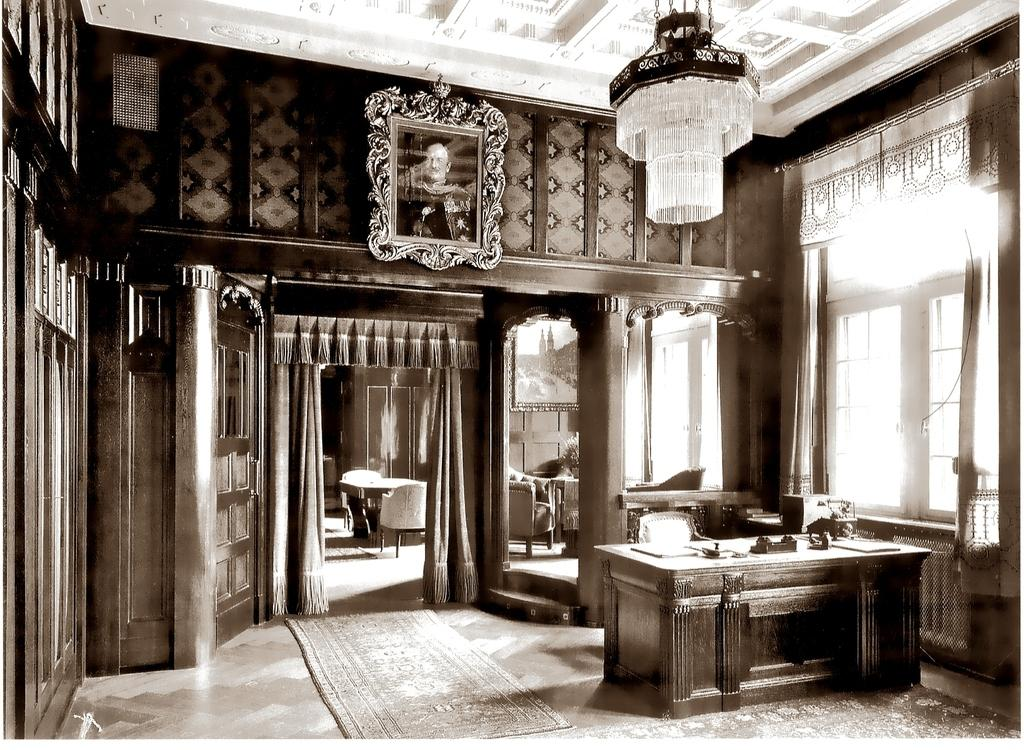What type of space is depicted in the image? The image shows an interior view of a building. What furniture is present in the image? There is a table and chairs in the image. What architectural features can be seen in the image? Windows, a wall, and the roof are visible in the image. How are the windows treated in the image? Curtains are associated with the windows in the image. What type of lighting is present in the image? A chandelier light is present in the image. What decorative item is visible in the image? There is a photo frame in the image. Can you describe any other objects present in the image? There are other objects in the image, but their specific details are not mentioned in the provided facts. What type of leather is used to make the chair in the image? There is no mention of leather or any specific material used for the chairs in the image. 